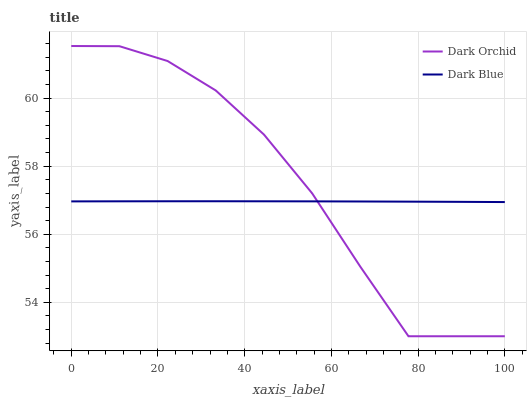Does Dark Blue have the minimum area under the curve?
Answer yes or no. Yes. Does Dark Orchid have the maximum area under the curve?
Answer yes or no. Yes. Does Dark Orchid have the minimum area under the curve?
Answer yes or no. No. Is Dark Blue the smoothest?
Answer yes or no. Yes. Is Dark Orchid the roughest?
Answer yes or no. Yes. Is Dark Orchid the smoothest?
Answer yes or no. No. Does Dark Orchid have the lowest value?
Answer yes or no. Yes. Does Dark Orchid have the highest value?
Answer yes or no. Yes. Does Dark Orchid intersect Dark Blue?
Answer yes or no. Yes. Is Dark Orchid less than Dark Blue?
Answer yes or no. No. Is Dark Orchid greater than Dark Blue?
Answer yes or no. No. 